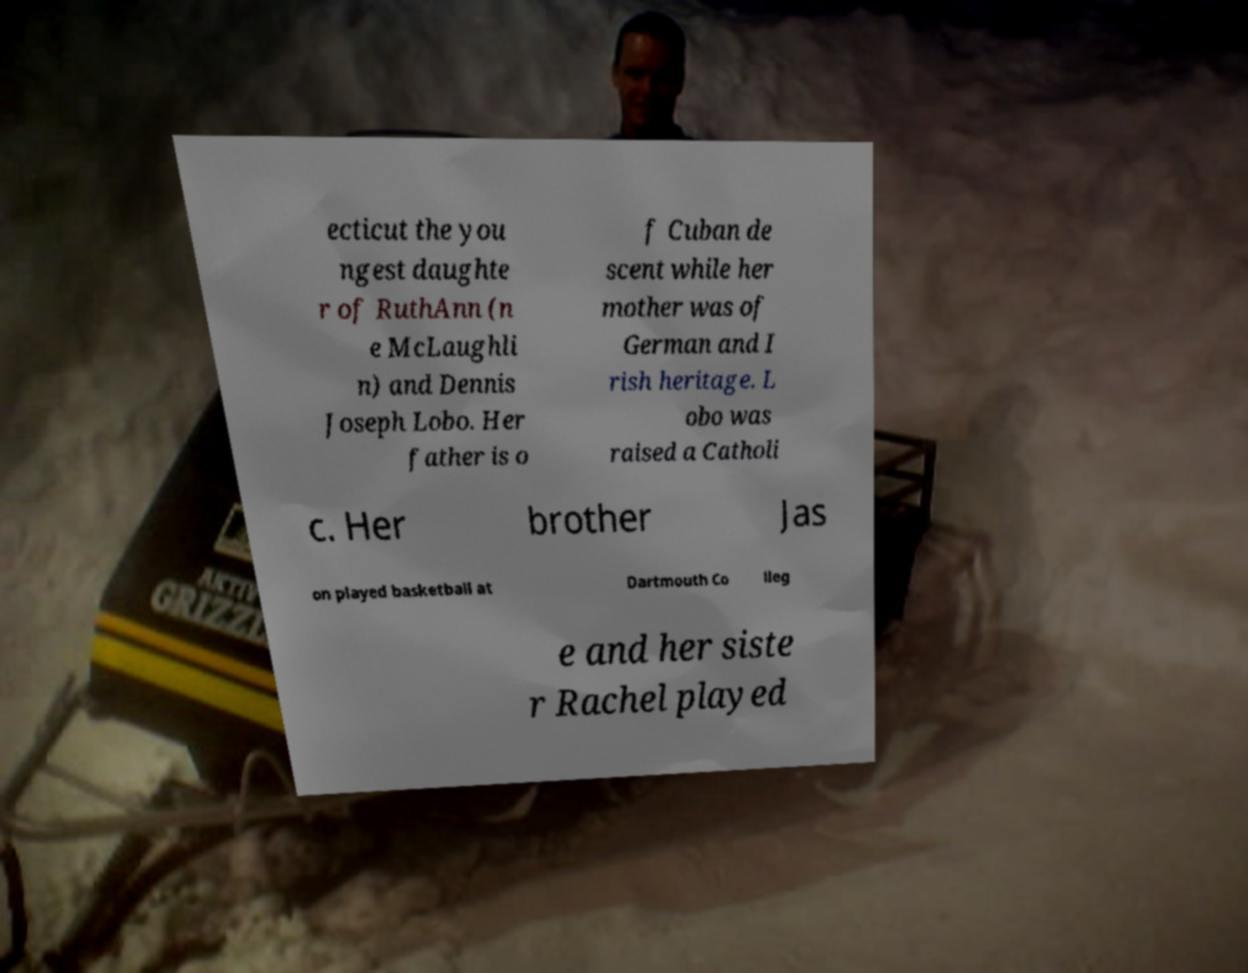Could you extract and type out the text from this image? ecticut the you ngest daughte r of RuthAnn (n e McLaughli n) and Dennis Joseph Lobo. Her father is o f Cuban de scent while her mother was of German and I rish heritage. L obo was raised a Catholi c. Her brother Jas on played basketball at Dartmouth Co lleg e and her siste r Rachel played 